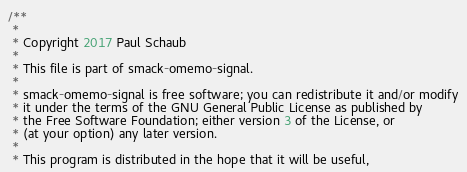Convert code to text. <code><loc_0><loc_0><loc_500><loc_500><_Java_>/**
 *
 * Copyright 2017 Paul Schaub
 *
 * This file is part of smack-omemo-signal.
 *
 * smack-omemo-signal is free software; you can redistribute it and/or modify
 * it under the terms of the GNU General Public License as published by
 * the Free Software Foundation; either version 3 of the License, or
 * (at your option) any later version.
 *
 * This program is distributed in the hope that it will be useful,</code> 